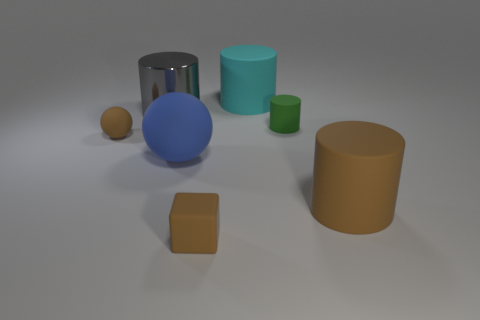There is a small matte thing that is the same color as the rubber cube; what shape is it?
Provide a short and direct response. Sphere. What size is the object that is both in front of the big metal object and left of the large rubber ball?
Provide a succinct answer. Small. Is there a big brown thing made of the same material as the tiny brown sphere?
Keep it short and to the point. Yes. The big cyan thing is what shape?
Your response must be concise. Cylinder. Do the brown rubber sphere and the cyan matte object have the same size?
Give a very brief answer. No. What number of other things are there of the same shape as the gray object?
Ensure brevity in your answer.  3. What shape is the big blue rubber object that is left of the green rubber object?
Provide a succinct answer. Sphere. There is a brown rubber object that is on the left side of the gray cylinder; is it the same shape as the thing on the right side of the green cylinder?
Your response must be concise. No. Is the number of tiny blocks that are behind the tiny rubber cube the same as the number of large shiny cubes?
Ensure brevity in your answer.  Yes. Is there any other thing that is the same size as the blue object?
Offer a terse response. Yes. 